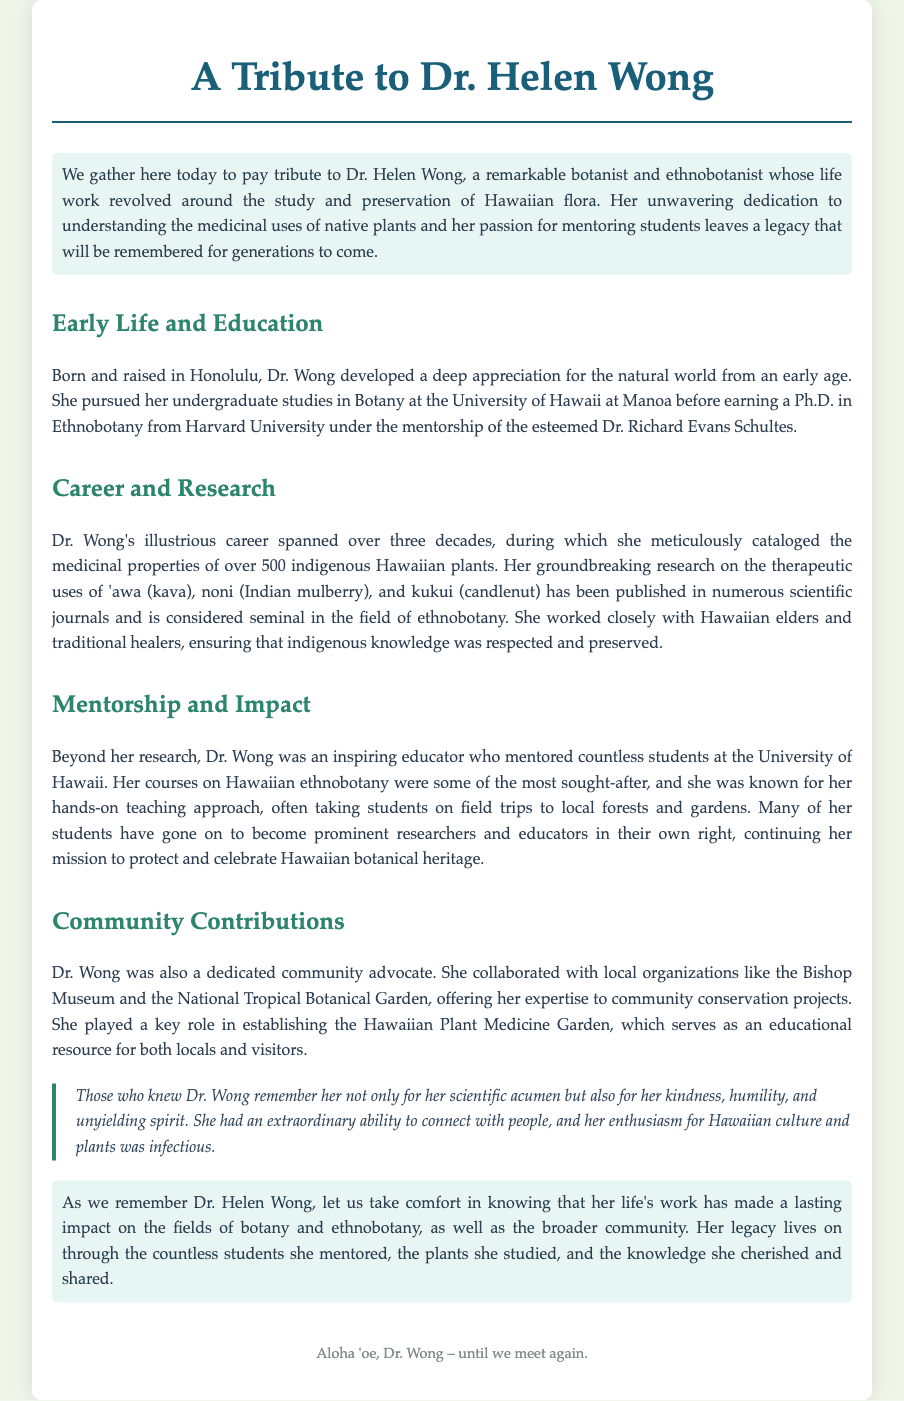What was Dr. Wong's field of study? Dr. Wong specialized in the study of plants and their cultural significance, specifically focusing on Hawaiian flora.
Answer: Ethnobotany How many indigenous Hawaiian plants did Dr. Wong catalog? The document states that Dr. Wong cataloged over 500 indigenous Hawaiian plants.
Answer: 500 Where did Dr. Wong earn her Ph.D.? The document specifies that Dr. Wong earned her Ph.D. in Ethnobotany from Harvard University.
Answer: Harvard University What role did Dr. Wong play in local conservation projects? Dr. Wong collaborated with local organizations on conservation projects, showing her dedication to community advocacy.
Answer: Community advocate Which plant's therapeutic uses did Dr. Wong research? The document mentions that Dr. Wong's research included the therapeutic uses of 'awa (kava).
Answer: 'awa (kava) What impact did Dr. Wong have on her students? Dr. Wong mentored countless students, many of whom became prominent researchers and educators in ethnobotany.
Answer: Mentoring students What was the Hawaiian Plant Medicine Garden's purpose? The garden was established as an educational resource for both locals and visitors.
Answer: Educational resource What qualities did people remember Dr. Wong for? The document notes that people remembered Dr. Wong for her kindness, humility, and spirit.
Answer: Kindness, humility, spirit What famous quote highlights Dr. Wong’s connection with people? The quote emphasizes Dr. Wong's extraordinary ability to connect with people and her infectious enthusiasm for Hawaiian culture.
Answer: “Extraordinary ability to connect with people” 